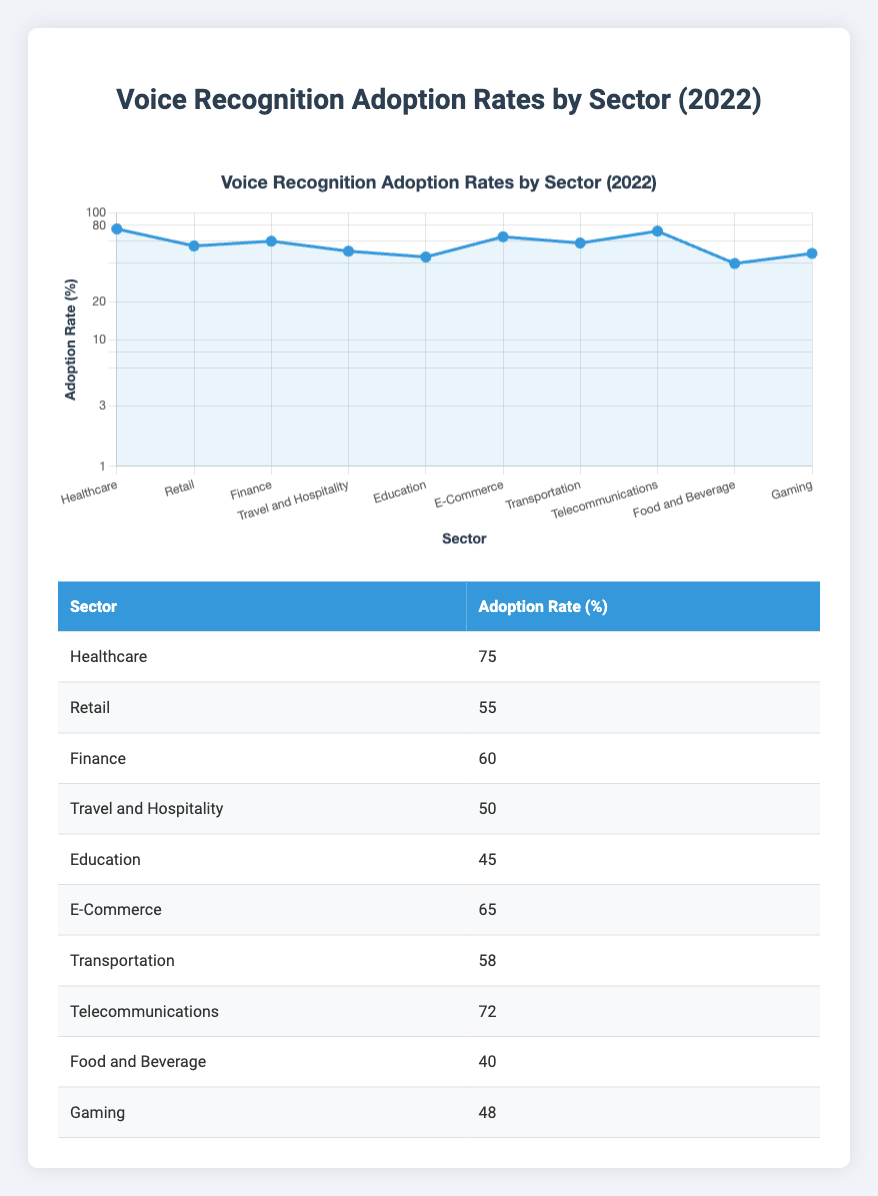What is the highest adoption rate of voice recognition features among sectors? The table shows that the highest adoption rate is for the Healthcare sector, which has a rate of 75%.
Answer: 75% Which sector has a lower adoption rate: Education or Transportation? According to the table, Education has a 45% adoption rate, and Transportation has a 58% adoption rate. Therefore, Education has the lower rate.
Answer: Education What is the average adoption rate of the sectors listed? To find the average, we sum the adoption rates: (75 + 55 + 60 + 50 + 45 + 65 + 58 + 72 + 40 + 48) =  63.58. Then, divide by the total number of sectors (10). The average is approximately 63.58%.
Answer: 63.58% Is the adoption rate for Gaming greater than that for Food and Beverage? The table shows Gaming has an adoption rate of 48% while Food and Beverage has 40%. Since 48% is greater than 40%, the statement is true.
Answer: Yes Which sectors have adoption rates greater than 60%? By inspecting the table, the sectors with rates greater than 60% are Healthcare (75%), E-Commerce (65%), and Telecommunications (72%).
Answer: Healthcare, E-Commerce, Telecommunications What is the difference in adoption rates between the Healthcare and Food and Beverage sectors? The Healthcare sector has a rate of 75% while Food and Beverage has a rate of 40%. To find the difference, we subtract: 75 - 40 = 35. Therefore, the difference is 35%.
Answer: 35% If the Retail sector decreases its adoption rate by 10%, what will be its new rate? The current adoption rate for Retail is 55%. If we decrease that by 10%, we calculate: 55 - 10 = 45%. The new adoption rate would be 45%.
Answer: 45% Which sector has the second highest adoption rate? The order of adoption rates from highest to lowest shows that the second highest rate is for Telecommunications at 72%.
Answer: Telecommunications How many sectors have adoption rates below 50%? By examining the table, the following sectors have adoption rates below 50%: Travel and Hospitality (50%), Education (45%), Food and Beverage (40%), and Gaming (48%). That gives a total of four sectors.
Answer: 4 